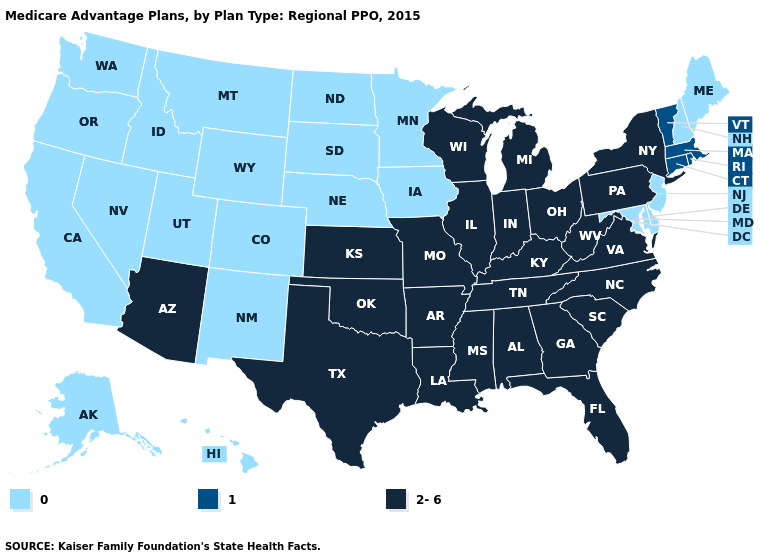What is the lowest value in the USA?
Answer briefly. 0. Name the states that have a value in the range 2-6?
Be succinct. Alabama, Arkansas, Arizona, Florida, Georgia, Illinois, Indiana, Kansas, Kentucky, Louisiana, Michigan, Missouri, Mississippi, North Carolina, New York, Ohio, Oklahoma, Pennsylvania, South Carolina, Tennessee, Texas, Virginia, Wisconsin, West Virginia. Does Hawaii have a lower value than New Mexico?
Give a very brief answer. No. How many symbols are there in the legend?
Short answer required. 3. Name the states that have a value in the range 1?
Keep it brief. Connecticut, Massachusetts, Rhode Island, Vermont. What is the value of California?
Short answer required. 0. Which states have the lowest value in the West?
Write a very short answer. Alaska, California, Colorado, Hawaii, Idaho, Montana, New Mexico, Nevada, Oregon, Utah, Washington, Wyoming. What is the value of North Carolina?
Answer briefly. 2-6. Which states hav the highest value in the West?
Quick response, please. Arizona. Does the map have missing data?
Answer briefly. No. What is the value of South Carolina?
Write a very short answer. 2-6. Which states hav the highest value in the West?
Write a very short answer. Arizona. Does Kansas have the highest value in the USA?
Answer briefly. Yes. What is the highest value in states that border Nebraska?
Keep it brief. 2-6. Name the states that have a value in the range 2-6?
Be succinct. Alabama, Arkansas, Arizona, Florida, Georgia, Illinois, Indiana, Kansas, Kentucky, Louisiana, Michigan, Missouri, Mississippi, North Carolina, New York, Ohio, Oklahoma, Pennsylvania, South Carolina, Tennessee, Texas, Virginia, Wisconsin, West Virginia. 